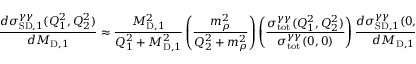Convert formula to latex. <formula><loc_0><loc_0><loc_500><loc_500>\frac { d \sigma _ { S D , 1 } ^ { \gamma \gamma } ( Q _ { 1 } ^ { 2 } , Q _ { 2 } ^ { 2 } ) } { d M _ { D , 1 } } \approx \frac { M _ { D , 1 } ^ { 2 } } { Q _ { 1 } ^ { 2 } + M _ { D , 1 } ^ { 2 } } \left ( \frac { m _ { \rho } ^ { 2 } } { Q _ { 2 } ^ { 2 } + m _ { \rho } ^ { 2 } } \right ) \left ( \frac { \sigma _ { t o t } ^ { \gamma \gamma } ( Q _ { 1 } ^ { 2 } , Q _ { 2 } ^ { 2 } ) } { \sigma _ { t o t } ^ { \gamma \gamma } ( 0 , 0 ) } \right ) \frac { d \sigma _ { S D , 1 } ^ { \gamma \gamma } ( 0 , 0 ) } { d M _ { D , 1 } }</formula> 